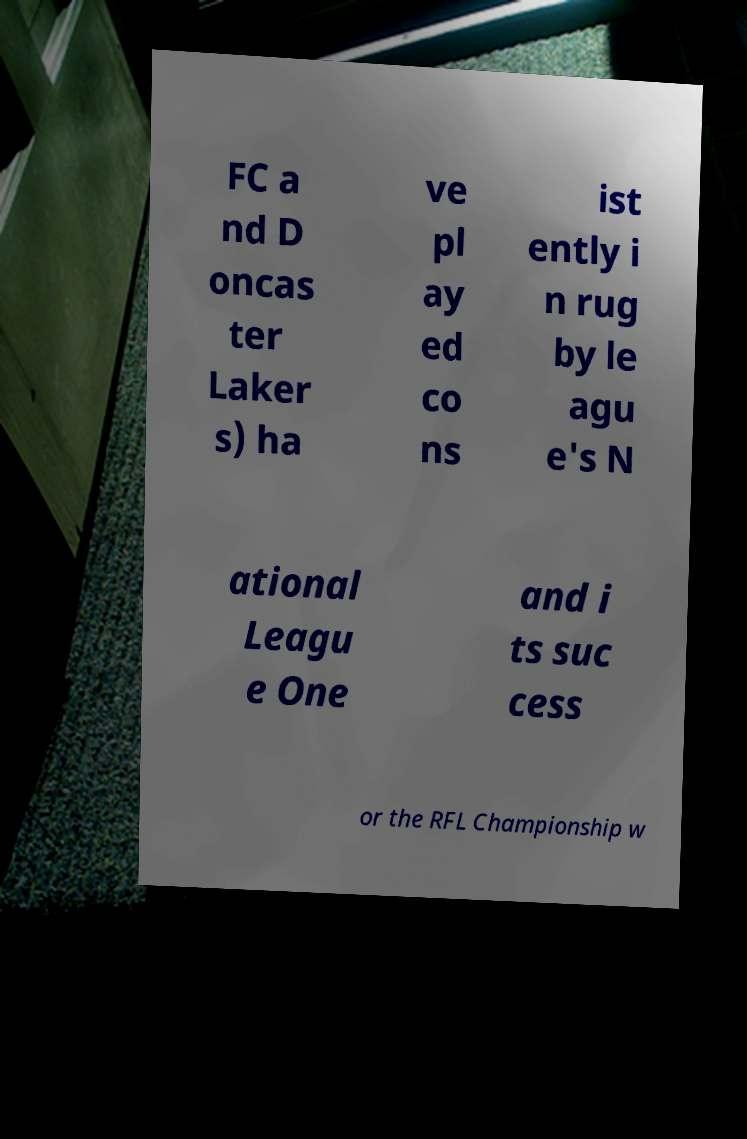Please identify and transcribe the text found in this image. FC a nd D oncas ter Laker s) ha ve pl ay ed co ns ist ently i n rug by le agu e's N ational Leagu e One and i ts suc cess or the RFL Championship w 